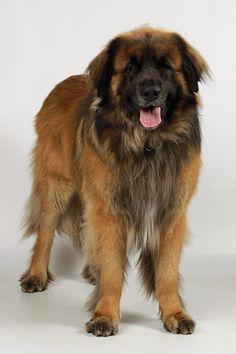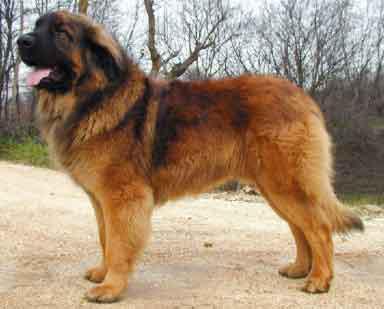The first image is the image on the left, the second image is the image on the right. Given the left and right images, does the statement "One image shows a dog on snow-covered ground." hold true? Answer yes or no. No. The first image is the image on the left, the second image is the image on the right. Considering the images on both sides, is "A dog is on a ground filled with snow." valid? Answer yes or no. No. 